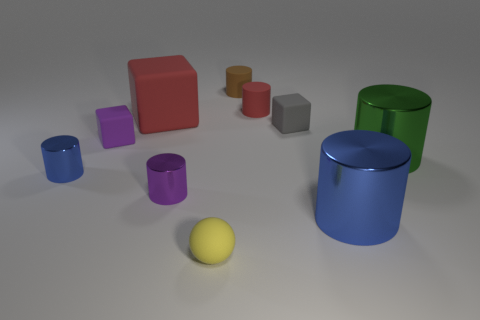What number of other objects are the same color as the big rubber block?
Keep it short and to the point. 1. Is the material of the small brown cylinder behind the large red rubber object the same as the small purple cube behind the big blue cylinder?
Ensure brevity in your answer.  Yes. Is the number of small blue cylinders that are to the right of the red cylinder the same as the number of red objects that are behind the yellow rubber object?
Make the answer very short. No. There is a small cylinder that is on the right side of the brown cylinder; what material is it?
Offer a terse response. Rubber. Is the number of big matte things less than the number of red balls?
Provide a short and direct response. No. There is a small object that is on the left side of the large red thing and in front of the large green metallic object; what shape is it?
Provide a short and direct response. Cylinder. What number of tiny shiny things are there?
Provide a succinct answer. 2. What is the material of the small purple thing that is left of the small metallic thing in front of the blue cylinder that is on the left side of the gray rubber thing?
Make the answer very short. Rubber. What number of big cylinders are on the left side of the rubber object that is on the left side of the large block?
Give a very brief answer. 0. There is another big shiny object that is the same shape as the big green object; what is its color?
Your answer should be very brief. Blue. 